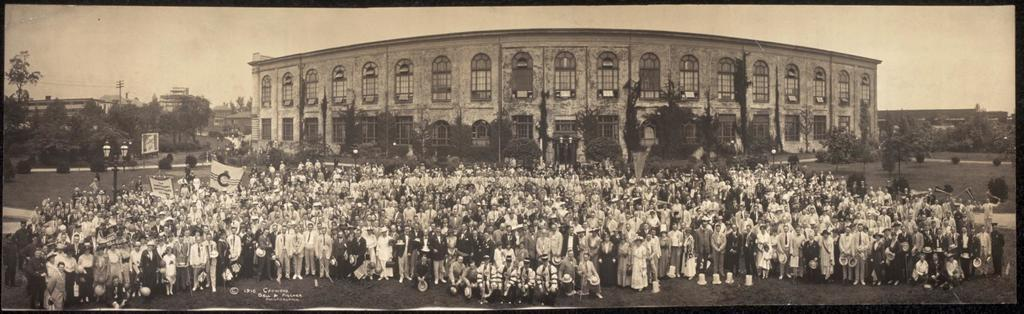What can be seen on the ground in the image? There are persons in different color dresses on a ground. What type of surface is the ground made of? The ground has grass. What can be seen in the background of the image? There are buildings, trees, and the sky visible in the background. Can you tell me how many pockets are visible on the persons in the image? There is no information about pockets on the persons in the image, so it cannot be determined. 